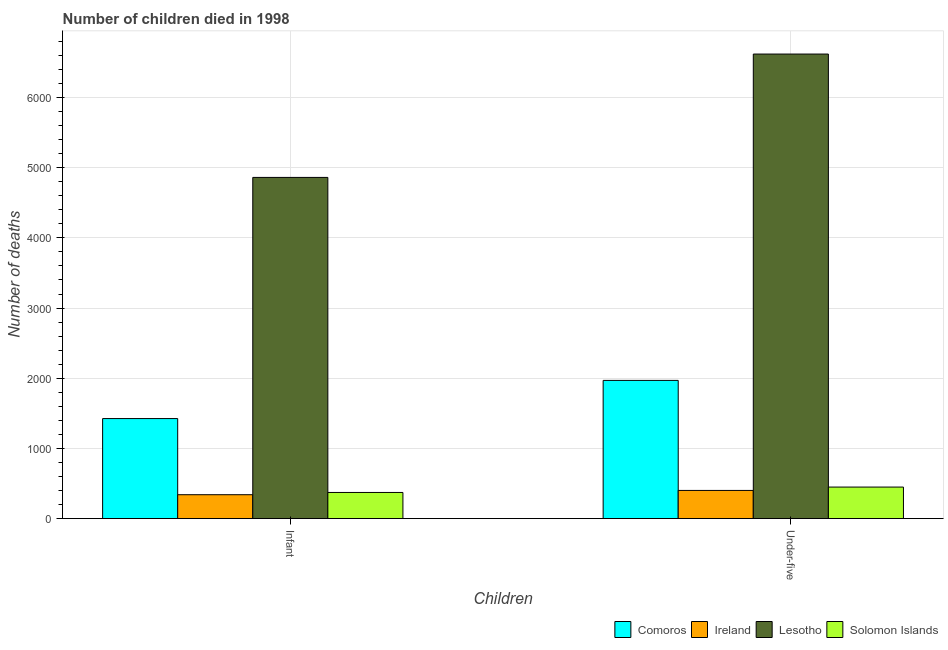How many groups of bars are there?
Your answer should be compact. 2. Are the number of bars per tick equal to the number of legend labels?
Provide a succinct answer. Yes. Are the number of bars on each tick of the X-axis equal?
Ensure brevity in your answer.  Yes. What is the label of the 2nd group of bars from the left?
Your response must be concise. Under-five. What is the number of infant deaths in Ireland?
Provide a short and direct response. 340. Across all countries, what is the maximum number of under-five deaths?
Your response must be concise. 6620. Across all countries, what is the minimum number of infant deaths?
Make the answer very short. 340. In which country was the number of infant deaths maximum?
Your response must be concise. Lesotho. In which country was the number of infant deaths minimum?
Keep it short and to the point. Ireland. What is the total number of under-five deaths in the graph?
Make the answer very short. 9439. What is the difference between the number of infant deaths in Ireland and that in Comoros?
Offer a terse response. -1085. What is the difference between the number of under-five deaths in Comoros and the number of infant deaths in Ireland?
Offer a very short reply. 1629. What is the average number of infant deaths per country?
Give a very brief answer. 1749.75. What is the difference between the number of under-five deaths and number of infant deaths in Comoros?
Your answer should be compact. 544. In how many countries, is the number of under-five deaths greater than 5200 ?
Keep it short and to the point. 1. What is the ratio of the number of infant deaths in Lesotho to that in Comoros?
Ensure brevity in your answer.  3.41. Is the number of infant deaths in Lesotho less than that in Solomon Islands?
Offer a terse response. No. In how many countries, is the number of under-five deaths greater than the average number of under-five deaths taken over all countries?
Keep it short and to the point. 1. What does the 2nd bar from the left in Under-five represents?
Make the answer very short. Ireland. What does the 4th bar from the right in Infant represents?
Provide a short and direct response. Comoros. Are all the bars in the graph horizontal?
Offer a terse response. No. Are the values on the major ticks of Y-axis written in scientific E-notation?
Offer a terse response. No. How many legend labels are there?
Give a very brief answer. 4. How are the legend labels stacked?
Keep it short and to the point. Horizontal. What is the title of the graph?
Offer a very short reply. Number of children died in 1998. Does "World" appear as one of the legend labels in the graph?
Provide a short and direct response. No. What is the label or title of the X-axis?
Your answer should be compact. Children. What is the label or title of the Y-axis?
Offer a very short reply. Number of deaths. What is the Number of deaths of Comoros in Infant?
Ensure brevity in your answer.  1425. What is the Number of deaths in Ireland in Infant?
Your response must be concise. 340. What is the Number of deaths of Lesotho in Infant?
Make the answer very short. 4862. What is the Number of deaths in Solomon Islands in Infant?
Your response must be concise. 372. What is the Number of deaths of Comoros in Under-five?
Keep it short and to the point. 1969. What is the Number of deaths in Ireland in Under-five?
Offer a terse response. 401. What is the Number of deaths of Lesotho in Under-five?
Provide a succinct answer. 6620. What is the Number of deaths in Solomon Islands in Under-five?
Ensure brevity in your answer.  449. Across all Children, what is the maximum Number of deaths in Comoros?
Make the answer very short. 1969. Across all Children, what is the maximum Number of deaths in Ireland?
Make the answer very short. 401. Across all Children, what is the maximum Number of deaths in Lesotho?
Ensure brevity in your answer.  6620. Across all Children, what is the maximum Number of deaths in Solomon Islands?
Your answer should be very brief. 449. Across all Children, what is the minimum Number of deaths in Comoros?
Ensure brevity in your answer.  1425. Across all Children, what is the minimum Number of deaths of Ireland?
Your answer should be very brief. 340. Across all Children, what is the minimum Number of deaths in Lesotho?
Your answer should be very brief. 4862. Across all Children, what is the minimum Number of deaths of Solomon Islands?
Keep it short and to the point. 372. What is the total Number of deaths of Comoros in the graph?
Your response must be concise. 3394. What is the total Number of deaths of Ireland in the graph?
Offer a terse response. 741. What is the total Number of deaths of Lesotho in the graph?
Keep it short and to the point. 1.15e+04. What is the total Number of deaths in Solomon Islands in the graph?
Keep it short and to the point. 821. What is the difference between the Number of deaths of Comoros in Infant and that in Under-five?
Ensure brevity in your answer.  -544. What is the difference between the Number of deaths of Ireland in Infant and that in Under-five?
Your answer should be very brief. -61. What is the difference between the Number of deaths in Lesotho in Infant and that in Under-five?
Your response must be concise. -1758. What is the difference between the Number of deaths in Solomon Islands in Infant and that in Under-five?
Your answer should be very brief. -77. What is the difference between the Number of deaths in Comoros in Infant and the Number of deaths in Ireland in Under-five?
Offer a terse response. 1024. What is the difference between the Number of deaths in Comoros in Infant and the Number of deaths in Lesotho in Under-five?
Your answer should be compact. -5195. What is the difference between the Number of deaths of Comoros in Infant and the Number of deaths of Solomon Islands in Under-five?
Keep it short and to the point. 976. What is the difference between the Number of deaths in Ireland in Infant and the Number of deaths in Lesotho in Under-five?
Offer a terse response. -6280. What is the difference between the Number of deaths of Ireland in Infant and the Number of deaths of Solomon Islands in Under-five?
Your response must be concise. -109. What is the difference between the Number of deaths of Lesotho in Infant and the Number of deaths of Solomon Islands in Under-five?
Provide a succinct answer. 4413. What is the average Number of deaths in Comoros per Children?
Your answer should be compact. 1697. What is the average Number of deaths in Ireland per Children?
Provide a short and direct response. 370.5. What is the average Number of deaths of Lesotho per Children?
Your answer should be very brief. 5741. What is the average Number of deaths of Solomon Islands per Children?
Give a very brief answer. 410.5. What is the difference between the Number of deaths in Comoros and Number of deaths in Ireland in Infant?
Provide a short and direct response. 1085. What is the difference between the Number of deaths in Comoros and Number of deaths in Lesotho in Infant?
Keep it short and to the point. -3437. What is the difference between the Number of deaths in Comoros and Number of deaths in Solomon Islands in Infant?
Your response must be concise. 1053. What is the difference between the Number of deaths of Ireland and Number of deaths of Lesotho in Infant?
Offer a very short reply. -4522. What is the difference between the Number of deaths of Ireland and Number of deaths of Solomon Islands in Infant?
Your answer should be compact. -32. What is the difference between the Number of deaths of Lesotho and Number of deaths of Solomon Islands in Infant?
Give a very brief answer. 4490. What is the difference between the Number of deaths in Comoros and Number of deaths in Ireland in Under-five?
Make the answer very short. 1568. What is the difference between the Number of deaths of Comoros and Number of deaths of Lesotho in Under-five?
Give a very brief answer. -4651. What is the difference between the Number of deaths of Comoros and Number of deaths of Solomon Islands in Under-five?
Provide a short and direct response. 1520. What is the difference between the Number of deaths in Ireland and Number of deaths in Lesotho in Under-five?
Your answer should be very brief. -6219. What is the difference between the Number of deaths in Ireland and Number of deaths in Solomon Islands in Under-five?
Offer a terse response. -48. What is the difference between the Number of deaths in Lesotho and Number of deaths in Solomon Islands in Under-five?
Your answer should be compact. 6171. What is the ratio of the Number of deaths in Comoros in Infant to that in Under-five?
Provide a short and direct response. 0.72. What is the ratio of the Number of deaths of Ireland in Infant to that in Under-five?
Your response must be concise. 0.85. What is the ratio of the Number of deaths in Lesotho in Infant to that in Under-five?
Your answer should be very brief. 0.73. What is the ratio of the Number of deaths in Solomon Islands in Infant to that in Under-five?
Give a very brief answer. 0.83. What is the difference between the highest and the second highest Number of deaths of Comoros?
Make the answer very short. 544. What is the difference between the highest and the second highest Number of deaths of Lesotho?
Provide a short and direct response. 1758. What is the difference between the highest and the lowest Number of deaths in Comoros?
Ensure brevity in your answer.  544. What is the difference between the highest and the lowest Number of deaths of Lesotho?
Offer a terse response. 1758. 